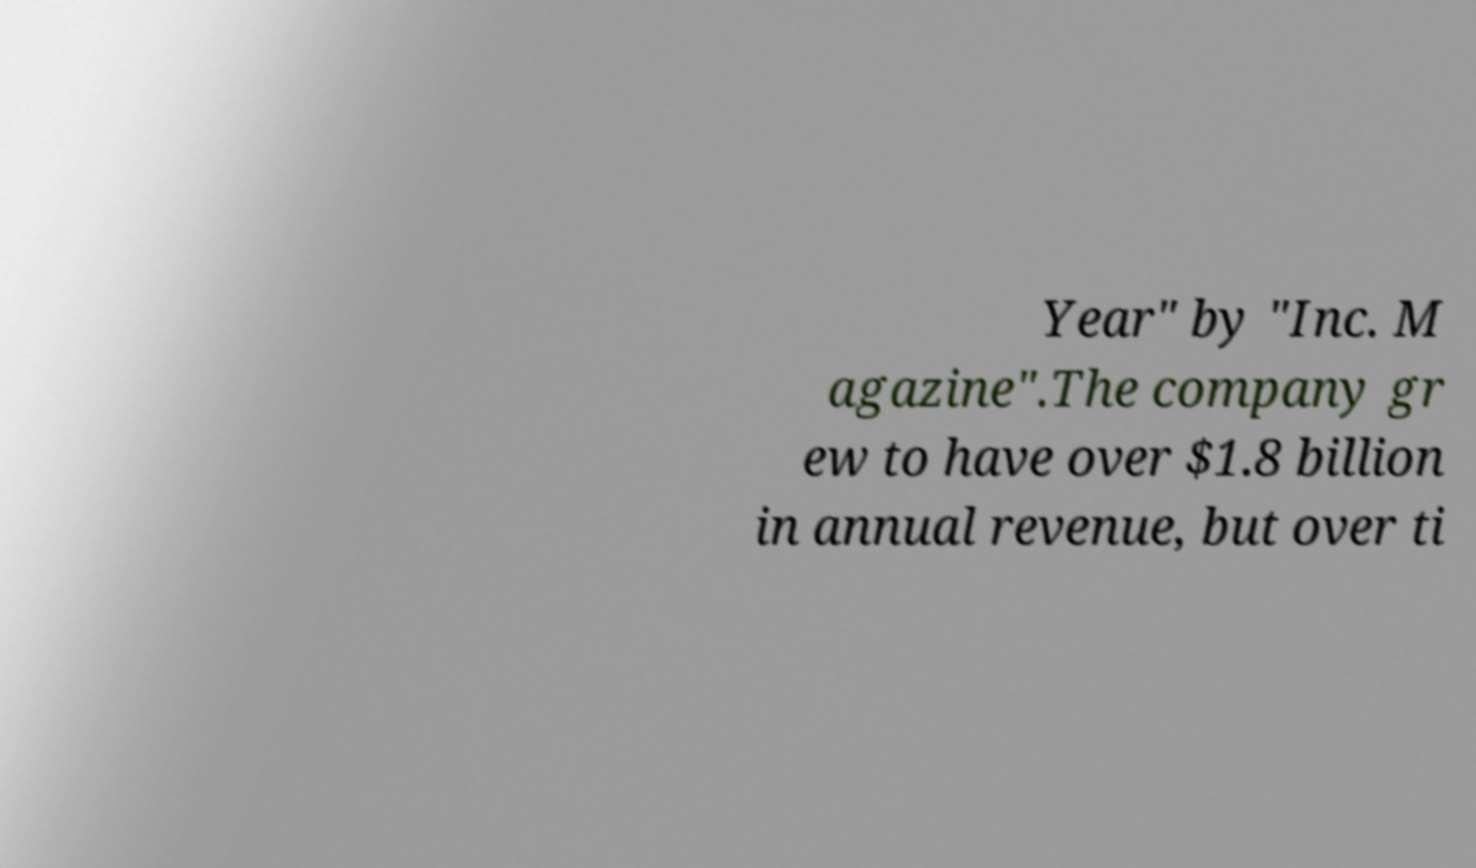Could you extract and type out the text from this image? Year" by "Inc. M agazine".The company gr ew to have over $1.8 billion in annual revenue, but over ti 